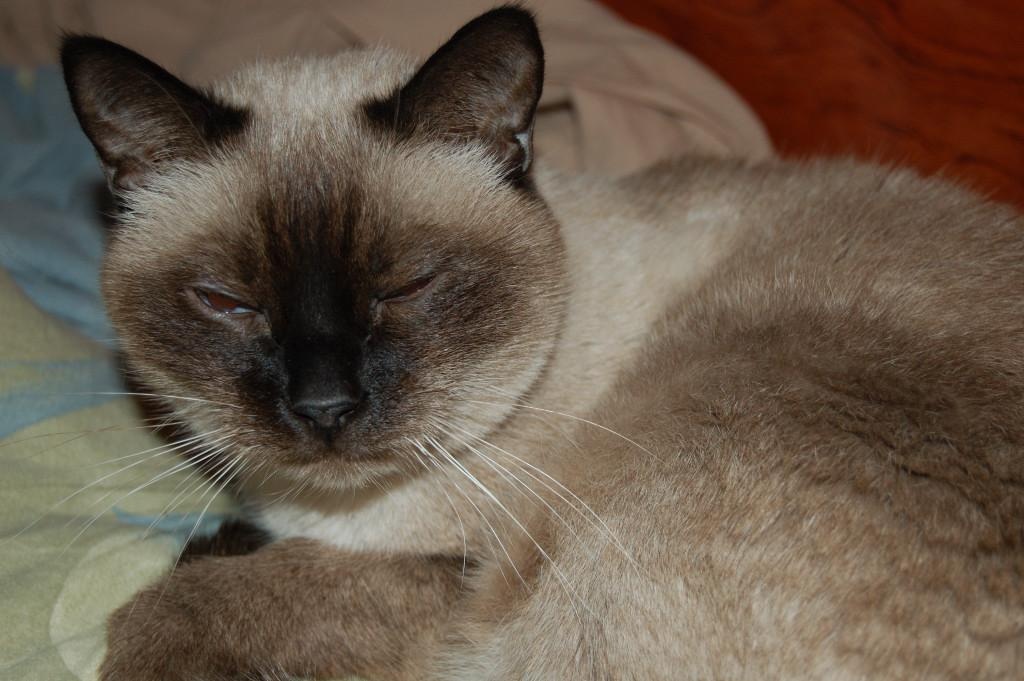What animal is present in the image? There is a cat in the image. What color combination is the cat in? The cat is in black and white color combination. Where is the cat located in the image? The cat is sitting on a bed. What is covering the bed in the image? The bed is covered with a bed sheet. How would you describe the background of the image? The background of the image is blurred. What type of pie is being baked on the stove in the image? There is no stove or pie present in the image; it features a cat sitting on a bed. What town is visible in the background of the image? There is no town visible in the background of the image; the background is blurred. 